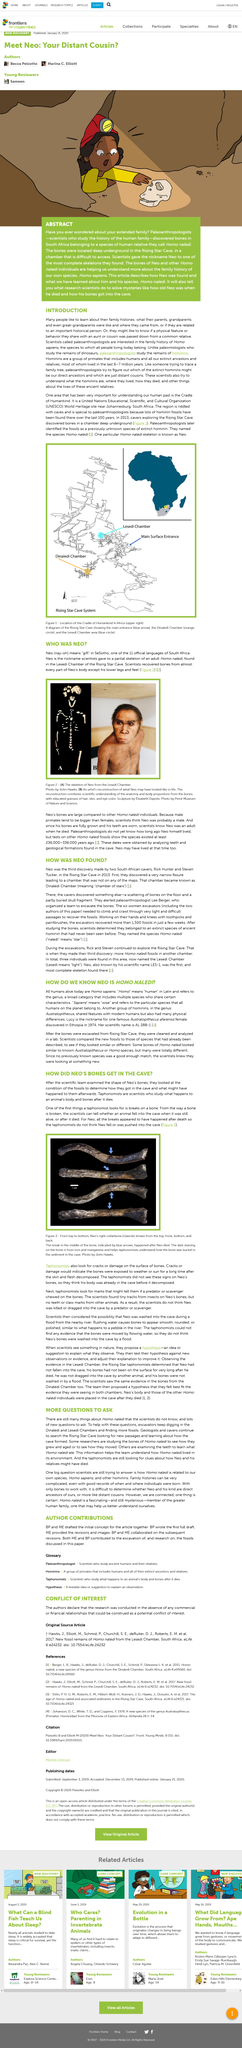Point out several critical features in this image. The partial skeleton of an adult Homo naledi, commonly known as "Neo," was given this nickname by scientists who discovered it in the Lesedi Chamber of the Rising Star Cave. The scientists did not recover bones from Neo's lower legs and feet during the analysis of his remains. The photo depicts Neo's collarbones. The Dinaledi Chamber has the name "Chamber of Stars," while the Dinaledi Chamber is known for its historic significance. The bones of Homo naledi are not similar only to Homo species, but also to other hominin species. 